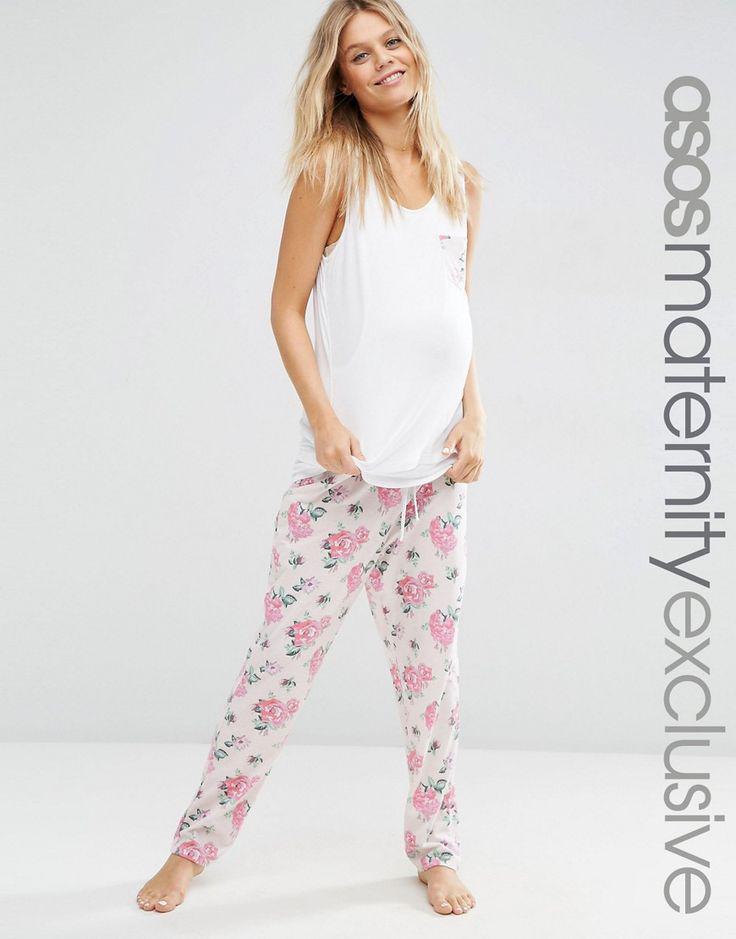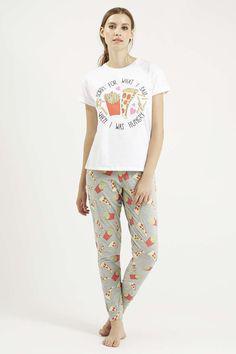The first image is the image on the left, the second image is the image on the right. Given the left and right images, does the statement "In the images, both models wear bottoms that are virtually the same length." hold true? Answer yes or no. Yes. 